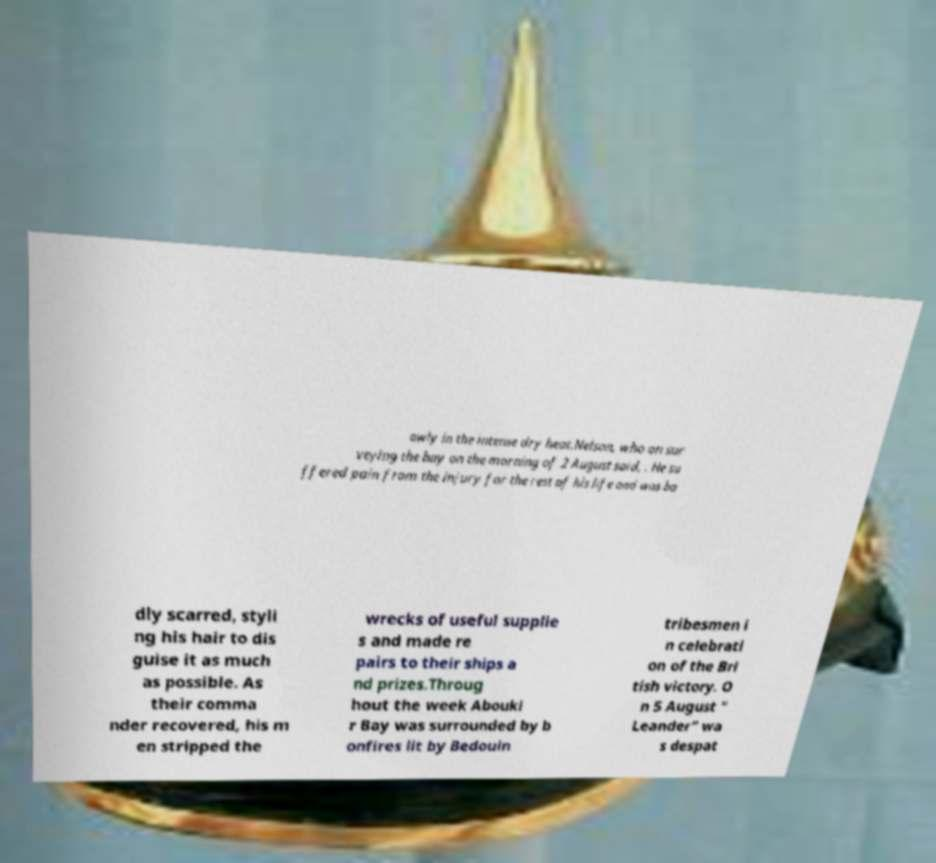Could you extract and type out the text from this image? owly in the intense dry heat.Nelson, who on sur veying the bay on the morning of 2 August said, . He su ffered pain from the injury for the rest of his life and was ba dly scarred, styli ng his hair to dis guise it as much as possible. As their comma nder recovered, his m en stripped the wrecks of useful supplie s and made re pairs to their ships a nd prizes.Throug hout the week Abouki r Bay was surrounded by b onfires lit by Bedouin tribesmen i n celebrati on of the Bri tish victory. O n 5 August " Leander" wa s despat 